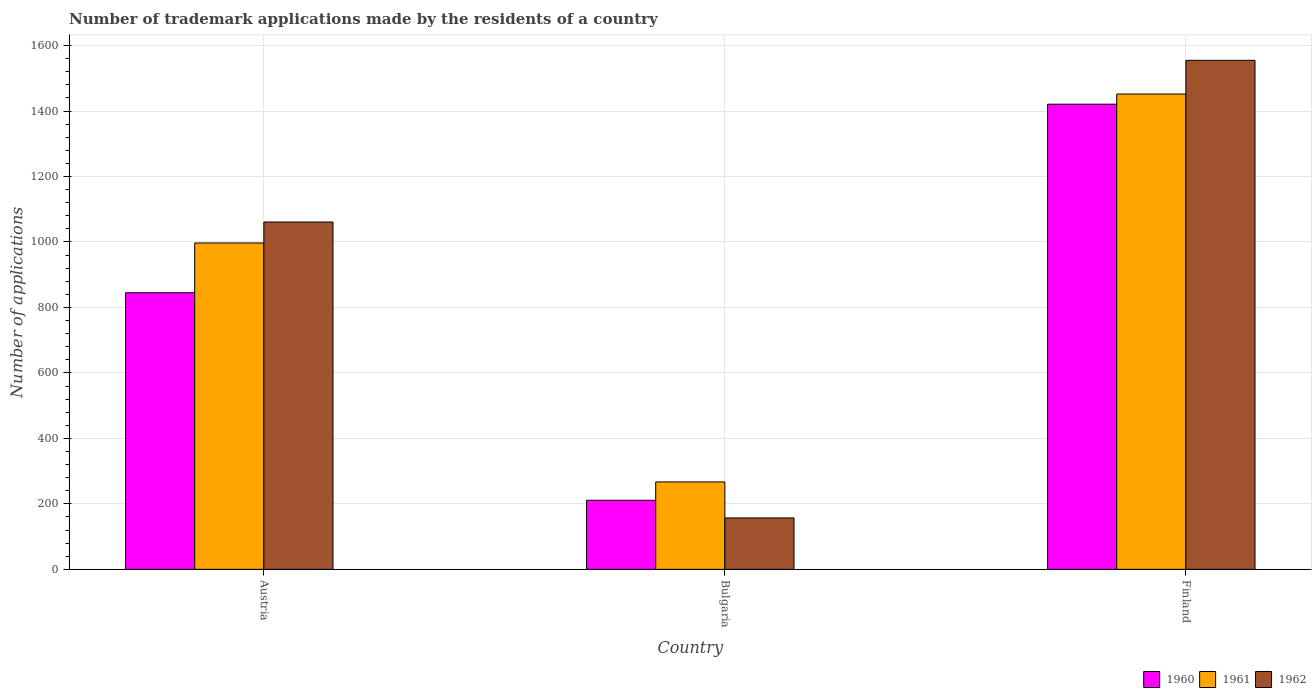How many different coloured bars are there?
Provide a short and direct response. 3. How many bars are there on the 3rd tick from the left?
Your answer should be compact. 3. How many bars are there on the 2nd tick from the right?
Give a very brief answer. 3. What is the label of the 1st group of bars from the left?
Ensure brevity in your answer.  Austria. What is the number of trademark applications made by the residents in 1961 in Bulgaria?
Your response must be concise. 267. Across all countries, what is the maximum number of trademark applications made by the residents in 1961?
Provide a short and direct response. 1452. Across all countries, what is the minimum number of trademark applications made by the residents in 1960?
Offer a terse response. 211. In which country was the number of trademark applications made by the residents in 1961 maximum?
Provide a succinct answer. Finland. In which country was the number of trademark applications made by the residents in 1962 minimum?
Your answer should be compact. Bulgaria. What is the total number of trademark applications made by the residents in 1961 in the graph?
Your answer should be very brief. 2716. What is the difference between the number of trademark applications made by the residents in 1962 in Austria and that in Finland?
Your response must be concise. -494. What is the difference between the number of trademark applications made by the residents in 1960 in Bulgaria and the number of trademark applications made by the residents in 1961 in Austria?
Offer a terse response. -786. What is the average number of trademark applications made by the residents in 1961 per country?
Ensure brevity in your answer.  905.33. What is the difference between the number of trademark applications made by the residents of/in 1960 and number of trademark applications made by the residents of/in 1962 in Finland?
Make the answer very short. -134. What is the ratio of the number of trademark applications made by the residents in 1960 in Bulgaria to that in Finland?
Your answer should be compact. 0.15. What is the difference between the highest and the second highest number of trademark applications made by the residents in 1961?
Offer a very short reply. -1185. What is the difference between the highest and the lowest number of trademark applications made by the residents in 1960?
Keep it short and to the point. 1210. In how many countries, is the number of trademark applications made by the residents in 1960 greater than the average number of trademark applications made by the residents in 1960 taken over all countries?
Your answer should be compact. 2. What does the 2nd bar from the left in Bulgaria represents?
Offer a terse response. 1961. How many bars are there?
Offer a very short reply. 9. Are all the bars in the graph horizontal?
Provide a short and direct response. No. Are the values on the major ticks of Y-axis written in scientific E-notation?
Offer a very short reply. No. Does the graph contain any zero values?
Offer a terse response. No. How are the legend labels stacked?
Make the answer very short. Horizontal. What is the title of the graph?
Your response must be concise. Number of trademark applications made by the residents of a country. What is the label or title of the X-axis?
Ensure brevity in your answer.  Country. What is the label or title of the Y-axis?
Your response must be concise. Number of applications. What is the Number of applications of 1960 in Austria?
Give a very brief answer. 845. What is the Number of applications of 1961 in Austria?
Your answer should be very brief. 997. What is the Number of applications of 1962 in Austria?
Provide a short and direct response. 1061. What is the Number of applications of 1960 in Bulgaria?
Keep it short and to the point. 211. What is the Number of applications of 1961 in Bulgaria?
Offer a terse response. 267. What is the Number of applications of 1962 in Bulgaria?
Offer a very short reply. 157. What is the Number of applications of 1960 in Finland?
Ensure brevity in your answer.  1421. What is the Number of applications in 1961 in Finland?
Offer a very short reply. 1452. What is the Number of applications of 1962 in Finland?
Your answer should be very brief. 1555. Across all countries, what is the maximum Number of applications of 1960?
Give a very brief answer. 1421. Across all countries, what is the maximum Number of applications in 1961?
Give a very brief answer. 1452. Across all countries, what is the maximum Number of applications in 1962?
Your response must be concise. 1555. Across all countries, what is the minimum Number of applications of 1960?
Ensure brevity in your answer.  211. Across all countries, what is the minimum Number of applications in 1961?
Provide a succinct answer. 267. Across all countries, what is the minimum Number of applications of 1962?
Your response must be concise. 157. What is the total Number of applications in 1960 in the graph?
Provide a succinct answer. 2477. What is the total Number of applications in 1961 in the graph?
Provide a short and direct response. 2716. What is the total Number of applications of 1962 in the graph?
Make the answer very short. 2773. What is the difference between the Number of applications in 1960 in Austria and that in Bulgaria?
Offer a terse response. 634. What is the difference between the Number of applications in 1961 in Austria and that in Bulgaria?
Offer a very short reply. 730. What is the difference between the Number of applications in 1962 in Austria and that in Bulgaria?
Your answer should be compact. 904. What is the difference between the Number of applications of 1960 in Austria and that in Finland?
Your answer should be compact. -576. What is the difference between the Number of applications of 1961 in Austria and that in Finland?
Offer a terse response. -455. What is the difference between the Number of applications in 1962 in Austria and that in Finland?
Give a very brief answer. -494. What is the difference between the Number of applications in 1960 in Bulgaria and that in Finland?
Provide a short and direct response. -1210. What is the difference between the Number of applications of 1961 in Bulgaria and that in Finland?
Provide a succinct answer. -1185. What is the difference between the Number of applications of 1962 in Bulgaria and that in Finland?
Ensure brevity in your answer.  -1398. What is the difference between the Number of applications of 1960 in Austria and the Number of applications of 1961 in Bulgaria?
Your answer should be very brief. 578. What is the difference between the Number of applications in 1960 in Austria and the Number of applications in 1962 in Bulgaria?
Provide a short and direct response. 688. What is the difference between the Number of applications of 1961 in Austria and the Number of applications of 1962 in Bulgaria?
Provide a succinct answer. 840. What is the difference between the Number of applications in 1960 in Austria and the Number of applications in 1961 in Finland?
Make the answer very short. -607. What is the difference between the Number of applications of 1960 in Austria and the Number of applications of 1962 in Finland?
Your answer should be compact. -710. What is the difference between the Number of applications in 1961 in Austria and the Number of applications in 1962 in Finland?
Offer a terse response. -558. What is the difference between the Number of applications in 1960 in Bulgaria and the Number of applications in 1961 in Finland?
Ensure brevity in your answer.  -1241. What is the difference between the Number of applications in 1960 in Bulgaria and the Number of applications in 1962 in Finland?
Your response must be concise. -1344. What is the difference between the Number of applications of 1961 in Bulgaria and the Number of applications of 1962 in Finland?
Provide a short and direct response. -1288. What is the average Number of applications in 1960 per country?
Your response must be concise. 825.67. What is the average Number of applications in 1961 per country?
Make the answer very short. 905.33. What is the average Number of applications in 1962 per country?
Offer a terse response. 924.33. What is the difference between the Number of applications of 1960 and Number of applications of 1961 in Austria?
Your response must be concise. -152. What is the difference between the Number of applications in 1960 and Number of applications in 1962 in Austria?
Your answer should be compact. -216. What is the difference between the Number of applications of 1961 and Number of applications of 1962 in Austria?
Provide a succinct answer. -64. What is the difference between the Number of applications in 1960 and Number of applications in 1961 in Bulgaria?
Make the answer very short. -56. What is the difference between the Number of applications in 1961 and Number of applications in 1962 in Bulgaria?
Keep it short and to the point. 110. What is the difference between the Number of applications of 1960 and Number of applications of 1961 in Finland?
Keep it short and to the point. -31. What is the difference between the Number of applications in 1960 and Number of applications in 1962 in Finland?
Your response must be concise. -134. What is the difference between the Number of applications of 1961 and Number of applications of 1962 in Finland?
Your response must be concise. -103. What is the ratio of the Number of applications of 1960 in Austria to that in Bulgaria?
Provide a succinct answer. 4. What is the ratio of the Number of applications of 1961 in Austria to that in Bulgaria?
Your answer should be very brief. 3.73. What is the ratio of the Number of applications of 1962 in Austria to that in Bulgaria?
Offer a very short reply. 6.76. What is the ratio of the Number of applications in 1960 in Austria to that in Finland?
Your answer should be very brief. 0.59. What is the ratio of the Number of applications of 1961 in Austria to that in Finland?
Offer a very short reply. 0.69. What is the ratio of the Number of applications in 1962 in Austria to that in Finland?
Your answer should be compact. 0.68. What is the ratio of the Number of applications in 1960 in Bulgaria to that in Finland?
Offer a very short reply. 0.15. What is the ratio of the Number of applications of 1961 in Bulgaria to that in Finland?
Offer a terse response. 0.18. What is the ratio of the Number of applications of 1962 in Bulgaria to that in Finland?
Provide a succinct answer. 0.1. What is the difference between the highest and the second highest Number of applications of 1960?
Offer a very short reply. 576. What is the difference between the highest and the second highest Number of applications of 1961?
Provide a succinct answer. 455. What is the difference between the highest and the second highest Number of applications of 1962?
Provide a short and direct response. 494. What is the difference between the highest and the lowest Number of applications of 1960?
Your response must be concise. 1210. What is the difference between the highest and the lowest Number of applications in 1961?
Offer a terse response. 1185. What is the difference between the highest and the lowest Number of applications of 1962?
Offer a very short reply. 1398. 